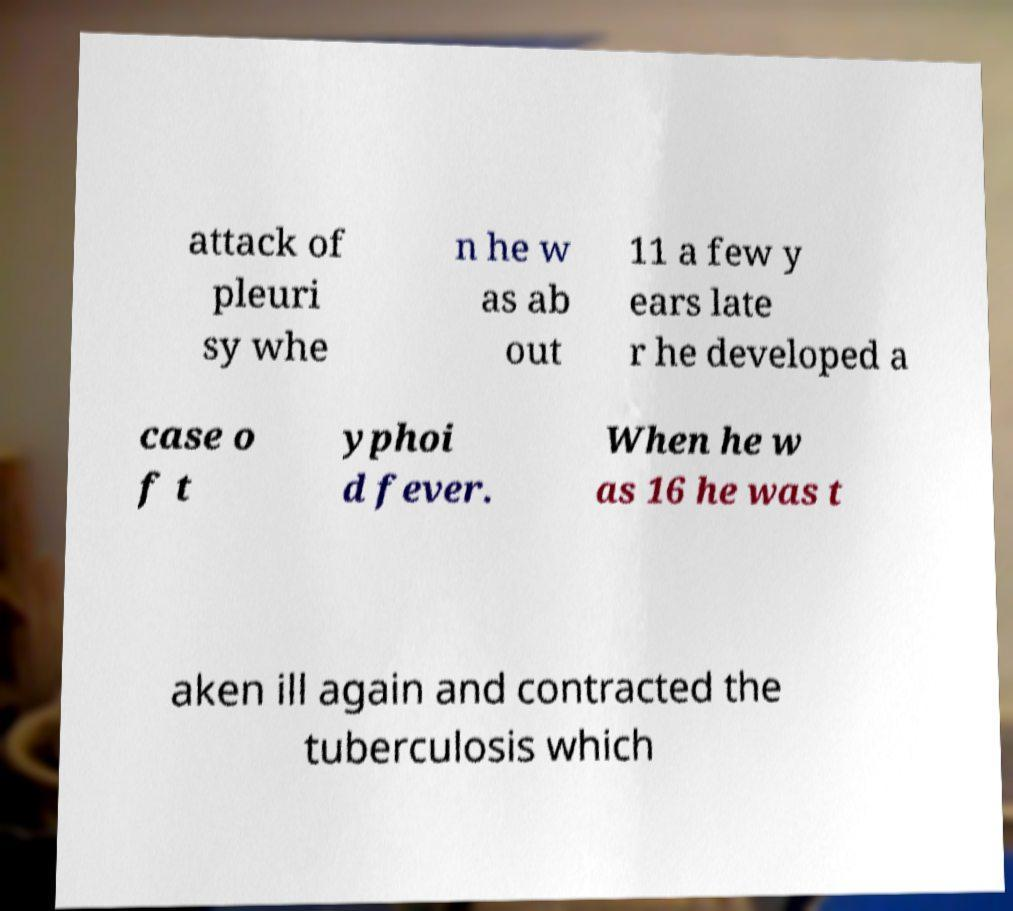There's text embedded in this image that I need extracted. Can you transcribe it verbatim? attack of pleuri sy whe n he w as ab out 11 a few y ears late r he developed a case o f t yphoi d fever. When he w as 16 he was t aken ill again and contracted the tuberculosis which 